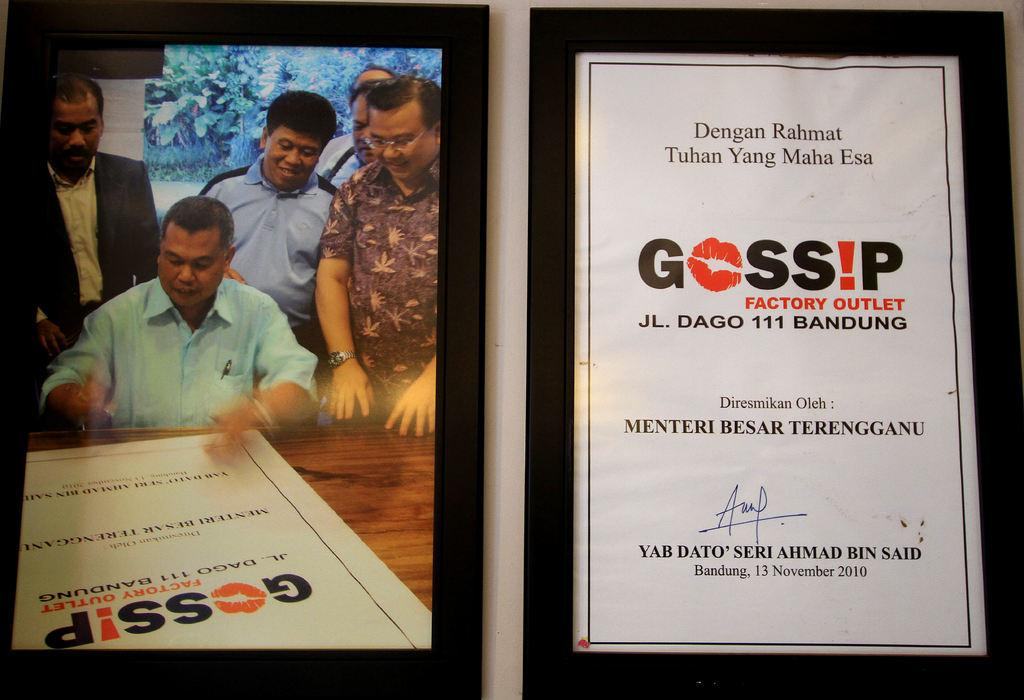<image>
Write a terse but informative summary of the picture. Two framed pictures that say Gossip Factory Outlet on them. 